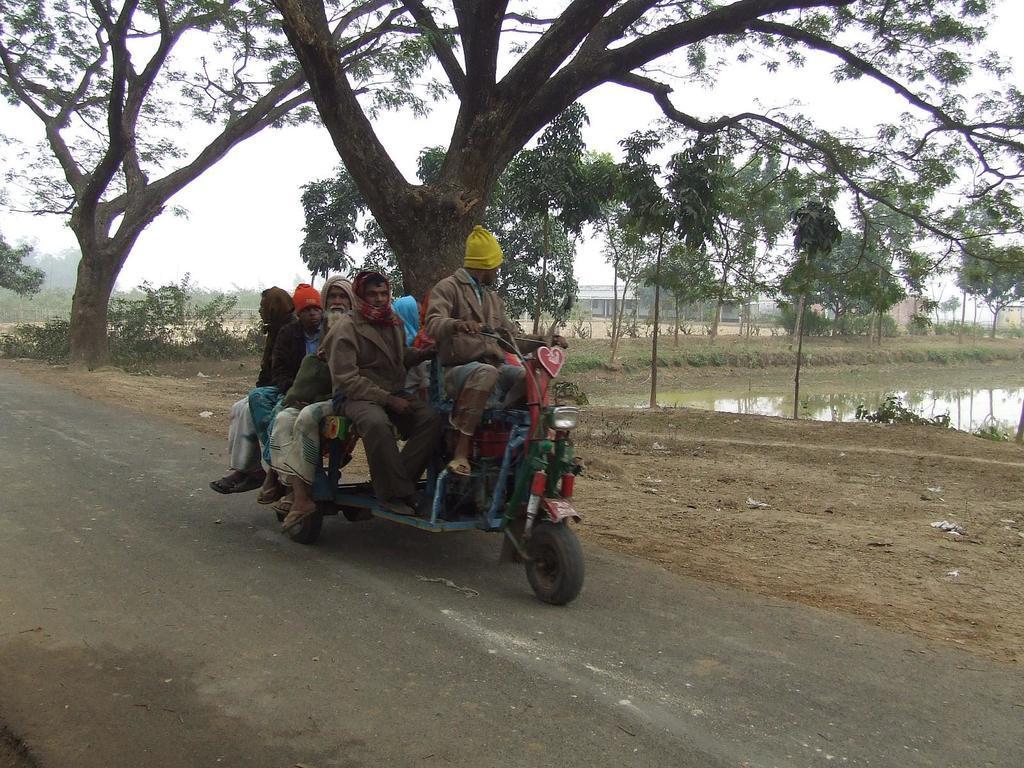How would you summarize this image in a sentence or two? In the foreground of this image, there is a vehicle moving on the road on which few persons are sitting on it. In the background, there is water, and, trees, few buildings and the sky. 